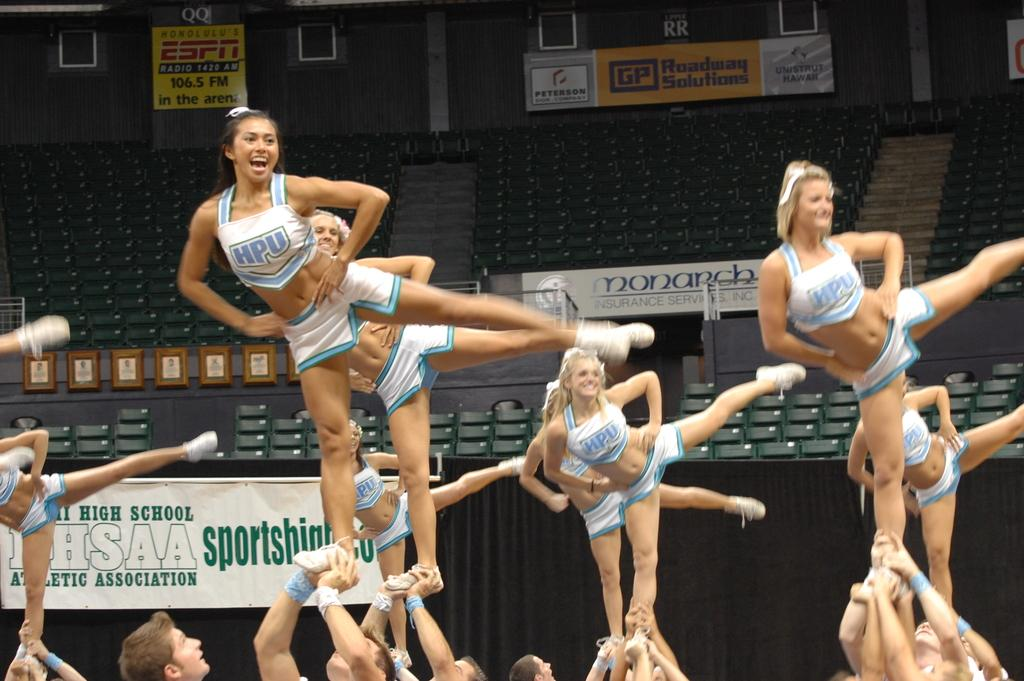<image>
Present a compact description of the photo's key features. A cheer team from HPU performs stunts in front of a High School Athletic Association sign. 